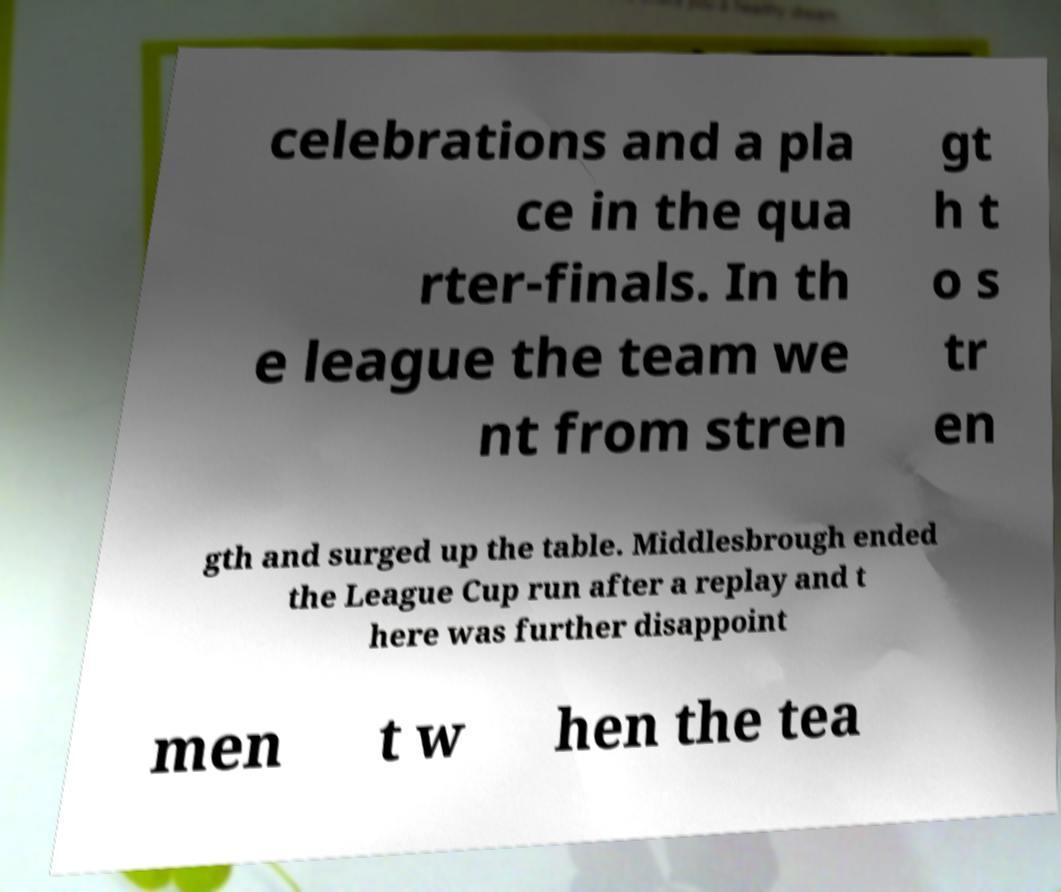Please read and relay the text visible in this image. What does it say? celebrations and a pla ce in the qua rter-finals. In th e league the team we nt from stren gt h t o s tr en gth and surged up the table. Middlesbrough ended the League Cup run after a replay and t here was further disappoint men t w hen the tea 